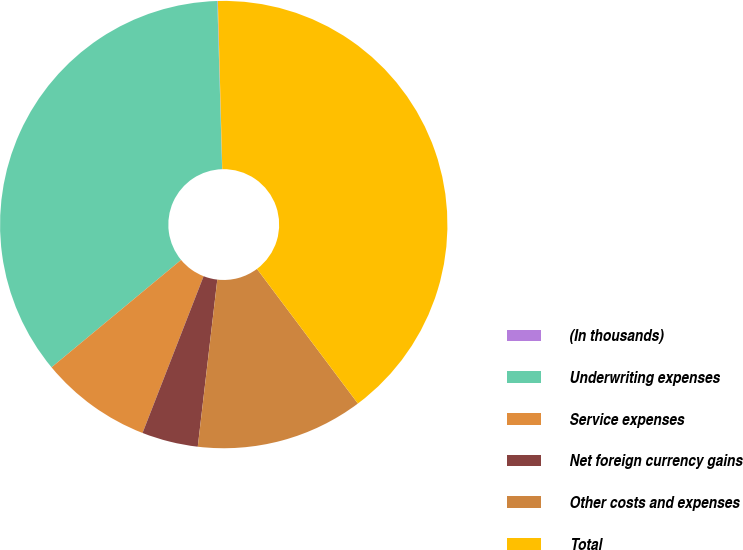Convert chart to OTSL. <chart><loc_0><loc_0><loc_500><loc_500><pie_chart><fcel>(In thousands)<fcel>Underwriting expenses<fcel>Service expenses<fcel>Net foreign currency gains<fcel>Other costs and expenses<fcel>Total<nl><fcel>0.04%<fcel>35.56%<fcel>8.07%<fcel>4.06%<fcel>12.09%<fcel>40.18%<nl></chart> 